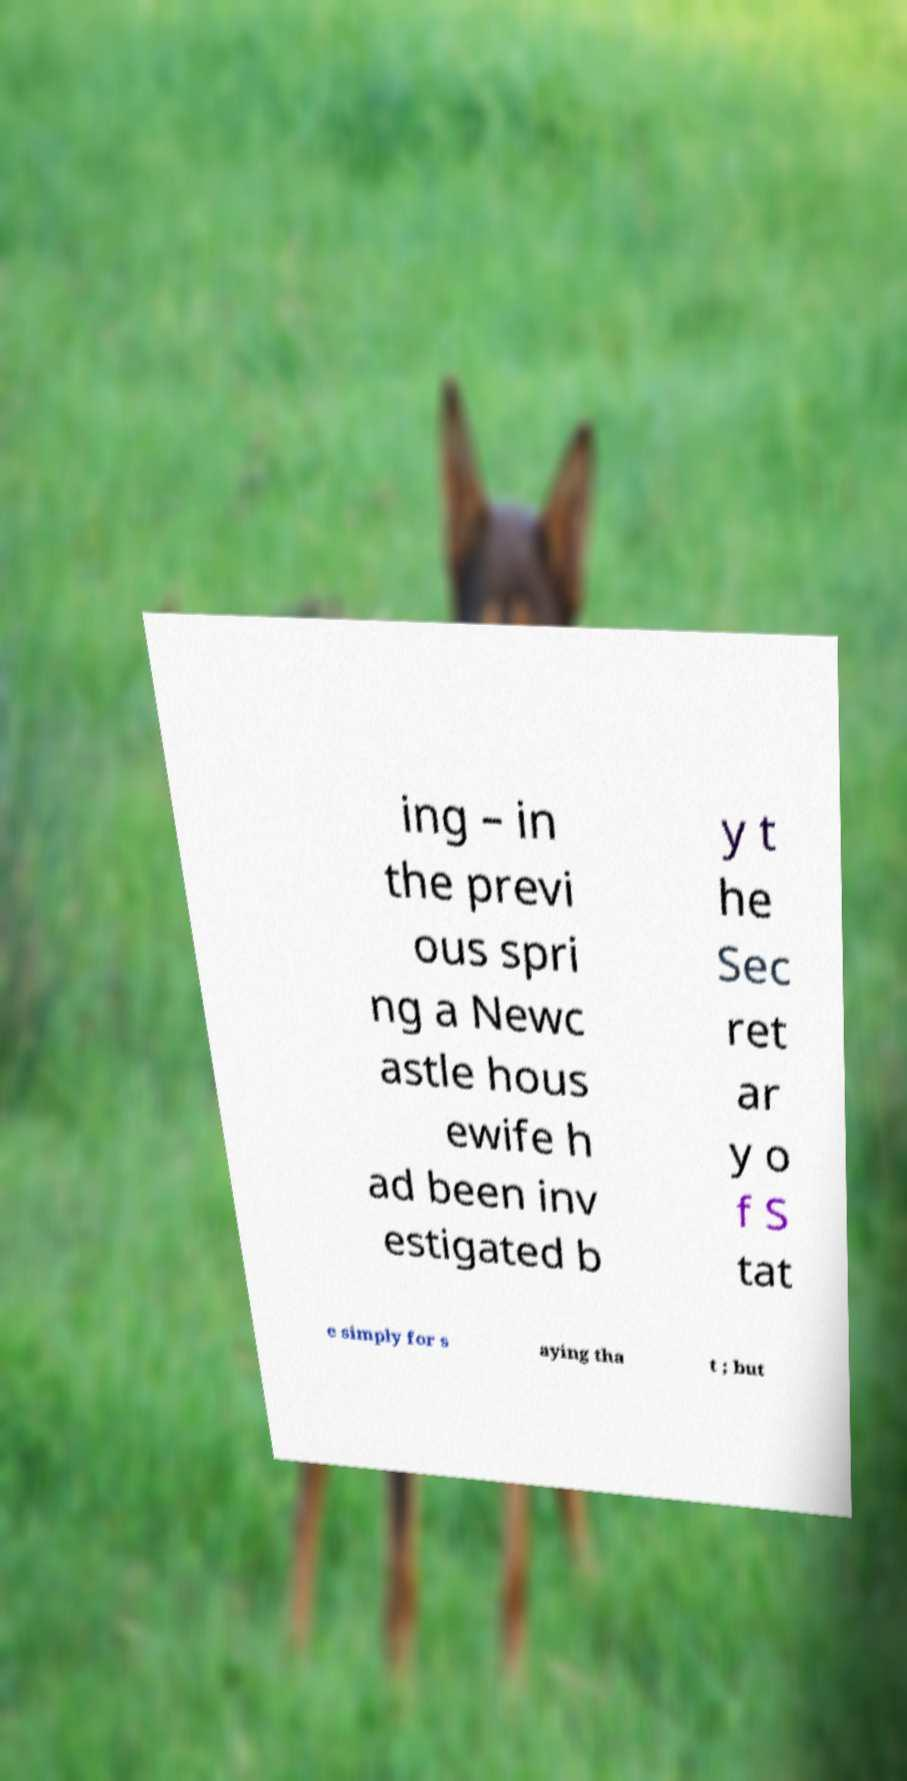Could you extract and type out the text from this image? ing – in the previ ous spri ng a Newc astle hous ewife h ad been inv estigated b y t he Sec ret ar y o f S tat e simply for s aying tha t ; but 